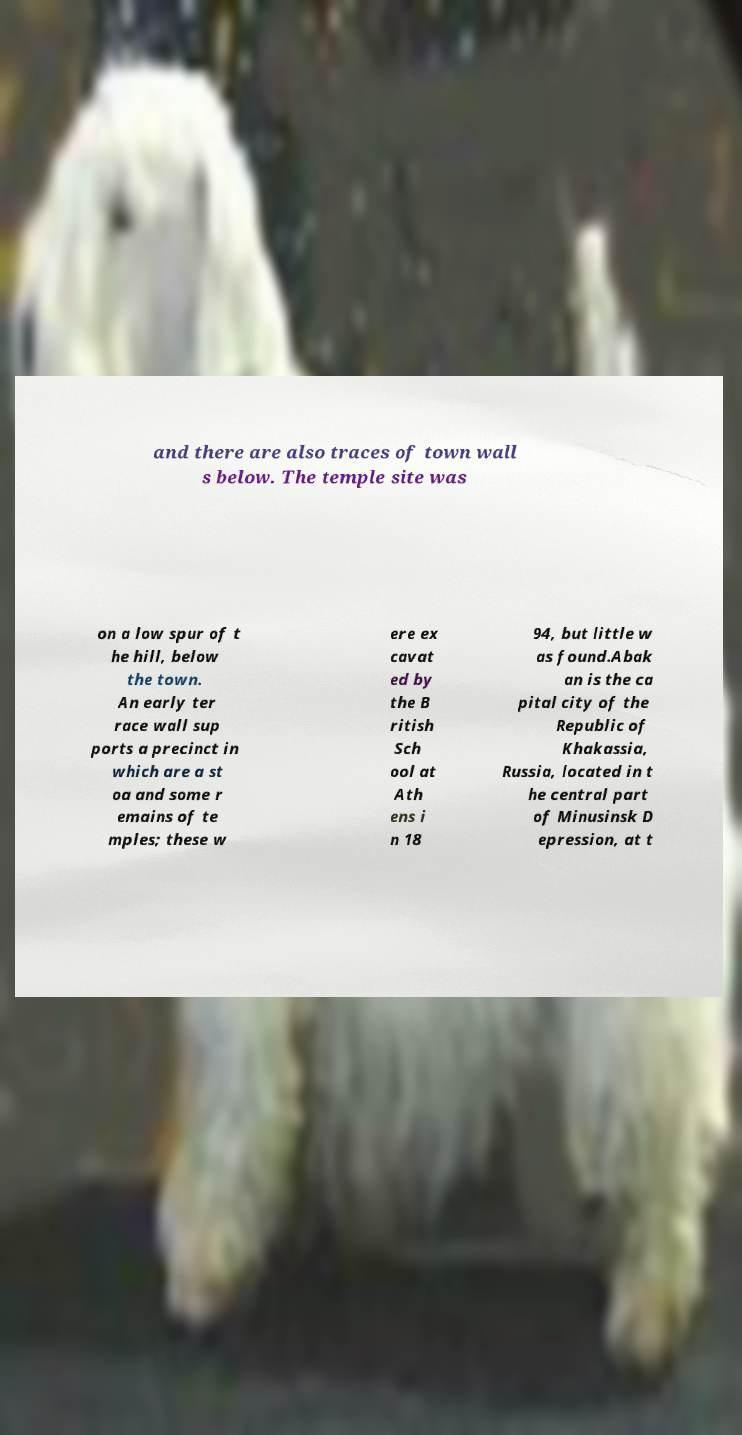Could you assist in decoding the text presented in this image and type it out clearly? and there are also traces of town wall s below. The temple site was on a low spur of t he hill, below the town. An early ter race wall sup ports a precinct in which are a st oa and some r emains of te mples; these w ere ex cavat ed by the B ritish Sch ool at Ath ens i n 18 94, but little w as found.Abak an is the ca pital city of the Republic of Khakassia, Russia, located in t he central part of Minusinsk D epression, at t 